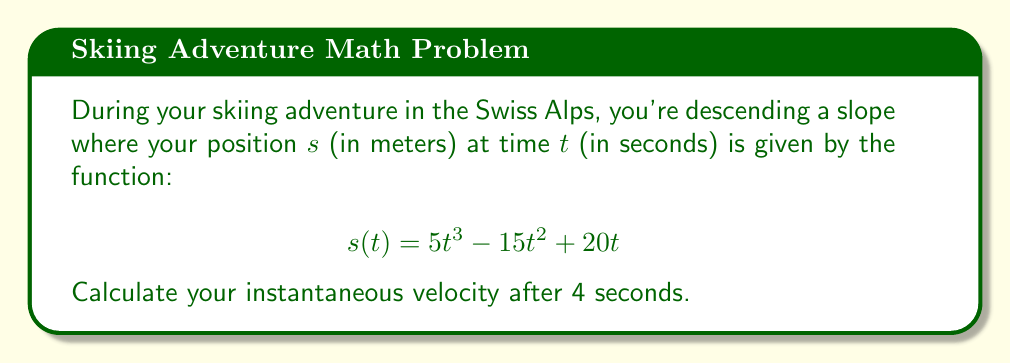Could you help me with this problem? To solve this problem, we need to follow these steps:

1) The velocity is the derivative of the position function with respect to time. So, we need to find $v(t) = \frac{ds}{dt}$.

2) Let's differentiate $s(t)$ using the power rule:

   $$\begin{align}
   v(t) &= \frac{d}{dt}(5t^3 - 15t^2 + 20t) \\
   &= 15t^2 - 30t + 20
   \end{align}$$

3) Now that we have the velocity function, we need to find the velocity at $t = 4$ seconds:

   $$\begin{align}
   v(4) &= 15(4)^2 - 30(4) + 20 \\
   &= 15(16) - 120 + 20 \\
   &= 240 - 120 + 20 \\
   &= 140
   \end{align}$$

Therefore, your instantaneous velocity after 4 seconds is 140 m/s.

Note: This is an extremely high velocity for skiing (about 504 km/h or 313 mph), which is not realistic. In a real-world scenario, factors like air resistance and friction would significantly reduce the speed.
Answer: 140 m/s 